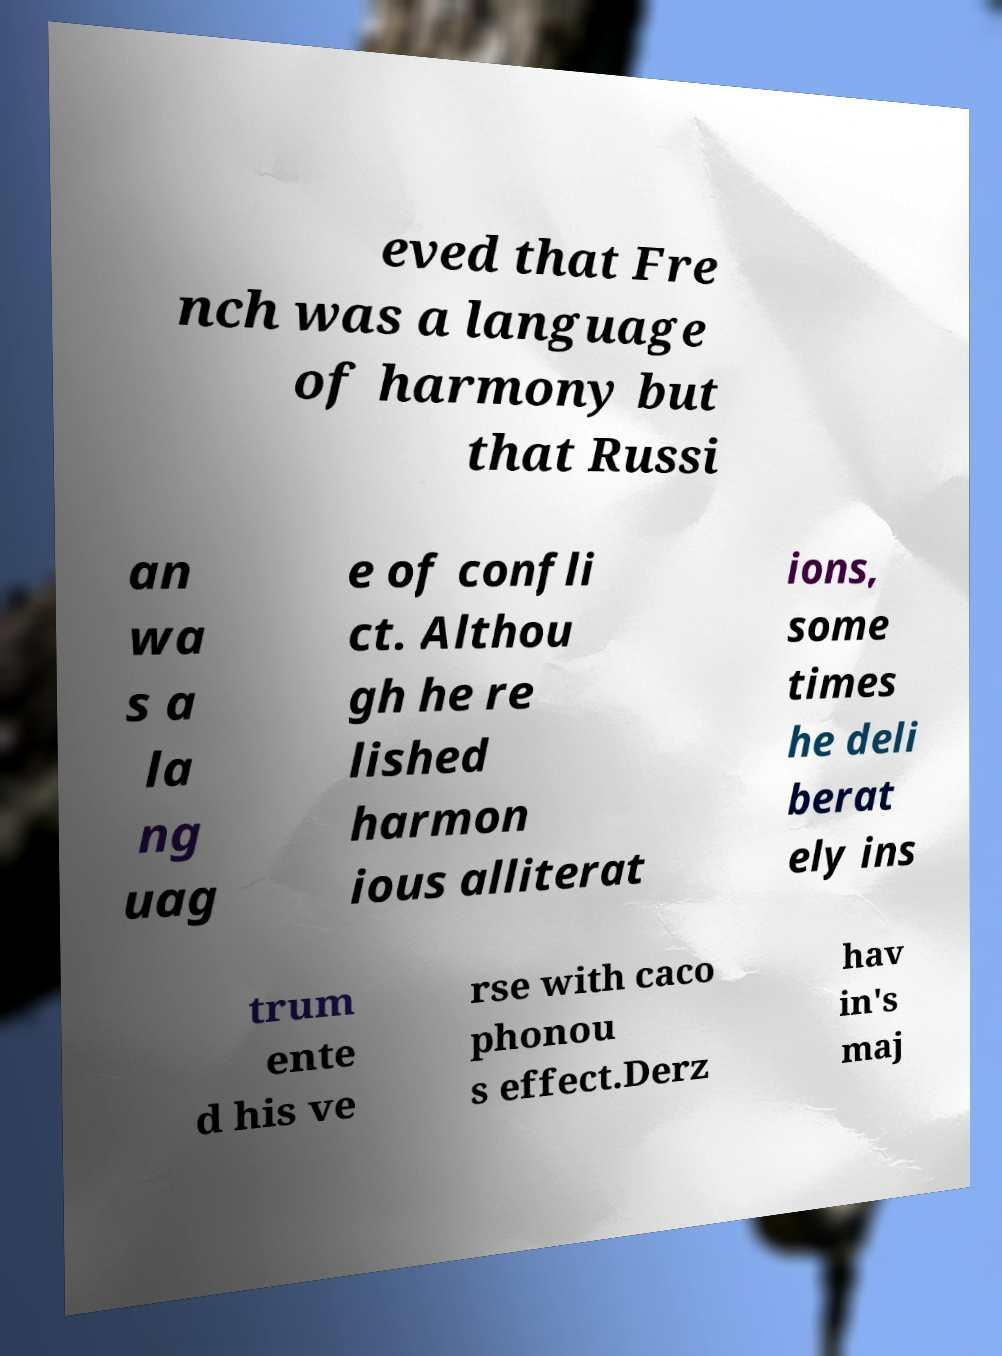There's text embedded in this image that I need extracted. Can you transcribe it verbatim? eved that Fre nch was a language of harmony but that Russi an wa s a la ng uag e of confli ct. Althou gh he re lished harmon ious alliterat ions, some times he deli berat ely ins trum ente d his ve rse with caco phonou s effect.Derz hav in's maj 